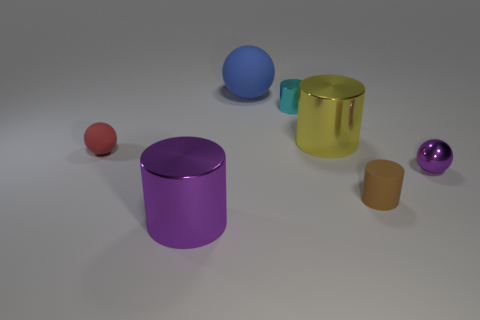What color is the rubber cylinder?
Make the answer very short. Brown. Does the tiny metal ball have the same color as the tiny shiny cylinder?
Offer a terse response. No. Is the large thing right of the cyan shiny cylinder made of the same material as the large thing that is behind the cyan thing?
Your answer should be very brief. No. There is a tiny brown thing that is the same shape as the large yellow thing; what is its material?
Provide a succinct answer. Rubber. Is the material of the large purple object the same as the small brown thing?
Offer a terse response. No. There is a tiny matte thing to the left of the rubber ball to the right of the big purple cylinder; what color is it?
Your response must be concise. Red. There is a brown object that is the same material as the blue ball; what size is it?
Keep it short and to the point. Small. What number of other things have the same shape as the big yellow metallic thing?
Provide a succinct answer. 3. What number of objects are either big metallic things that are in front of the brown rubber cylinder or matte balls that are behind the small matte sphere?
Offer a terse response. 2. There is a big metal thing that is behind the big purple shiny object; how many big purple metal things are in front of it?
Give a very brief answer. 1. 